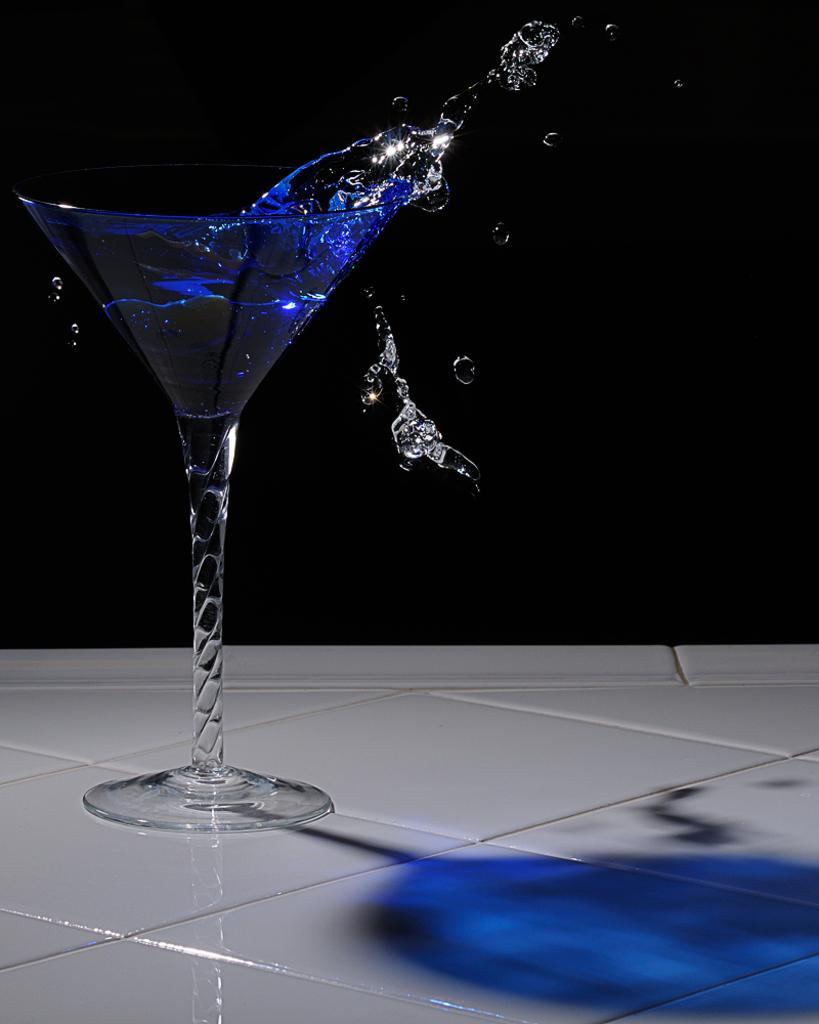In one or two sentences, can you explain what this image depicts? In the picture we can see a white color table on it, we can see a wine glass with some blue color liquid on it which is flowing out of the glass. 